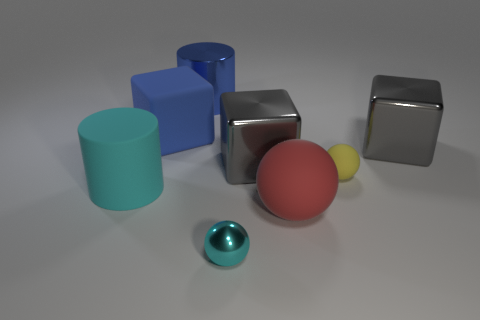Subtract all matte spheres. How many spheres are left? 1 Subtract all gray balls. How many gray cubes are left? 2 Subtract 1 blocks. How many blocks are left? 2 Add 2 tiny green objects. How many objects exist? 10 Subtract all blocks. How many objects are left? 5 Add 4 big matte objects. How many big matte objects exist? 7 Subtract 0 red cylinders. How many objects are left? 8 Subtract all small green balls. Subtract all tiny matte things. How many objects are left? 7 Add 2 small shiny things. How many small shiny things are left? 3 